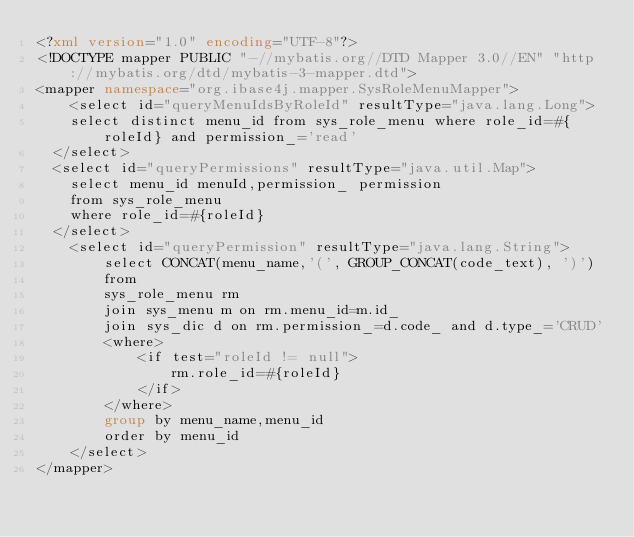<code> <loc_0><loc_0><loc_500><loc_500><_XML_><?xml version="1.0" encoding="UTF-8"?>
<!DOCTYPE mapper PUBLIC "-//mybatis.org//DTD Mapper 3.0//EN" "http://mybatis.org/dtd/mybatis-3-mapper.dtd">
<mapper namespace="org.ibase4j.mapper.SysRoleMenuMapper">
	<select id="queryMenuIdsByRoleId" resultType="java.lang.Long">
  	select distinct menu_id from sys_role_menu where role_id=#{roleId} and permission_='read'
  </select>
  <select id="queryPermissions" resultType="java.util.Map">
  	select menu_id menuId,permission_ permission
  	from sys_role_menu
	where role_id=#{roleId}
  </select>
	<select id="queryPermission" resultType="java.lang.String">
		select CONCAT(menu_name,'(', GROUP_CONCAT(code_text), ')')
		from
		sys_role_menu rm
		join sys_menu m on rm.menu_id=m.id_
		join sys_dic d on rm.permission_=d.code_ and d.type_='CRUD'
		<where>
			<if test="roleId != null">
				rm.role_id=#{roleId}
			</if>
		</where>
		group by menu_name,menu_id
		order by menu_id
	</select>
</mapper></code> 